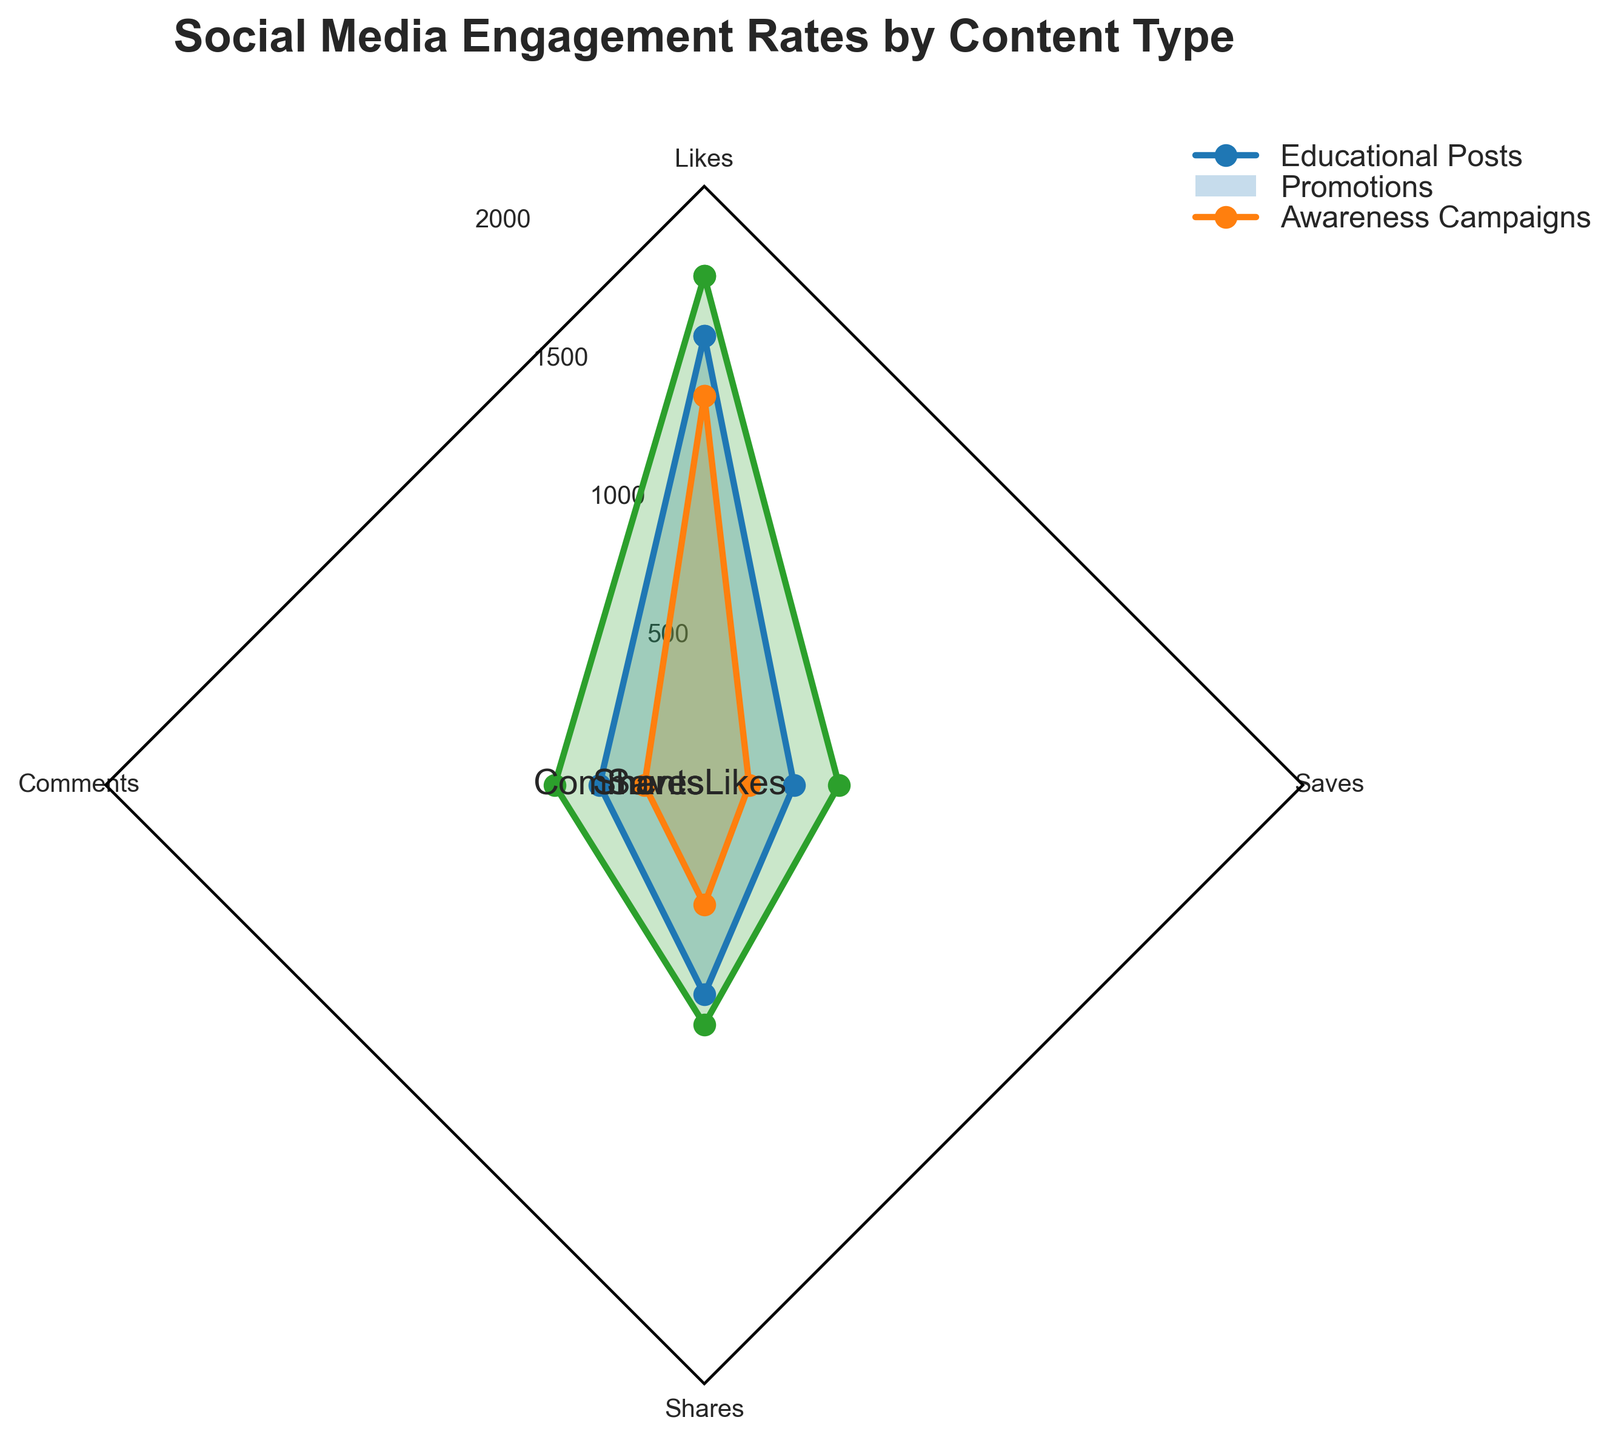What is the title of the radar chart? The title is displayed prominently at the top of the chart. It summarizes the content of the chart.
Answer: Social Media Engagement Rates by Content Type How many content types are represented in the chart? The chart has lines connecting data points labeled with content types. By counting the spokes, we determine the number of content types.
Answer: 4 Which content type has the highest number of likes? By looking at the lines extending furthest from the center on the "Likes" spoke, we can see which one has the highest value.
Answer: Awareness Campaigns Which engagement metric has the lowest value for Promotions? By inspecting the spokes labeled with metrics and checking the extension of the line for Promotions, we find the lowest point.
Answer: Saves What is the total number of comments for Educational Posts and Promotions combined? By adding the values from the "Comments" spoke for both Educational Posts and Promotions.
Answer: 550 How does the number of shares for Awareness Campaigns compare to Promotions? We compare the line extents for both Awareness Campaigns and Promotions on the "Shares" spoke.
Answer: Awareness Campaigns > Promotions What is the average number of saves across all content types? We sum the values for "Saves" for each content type and divide by the number of content types. (300 + 150 + 450) / 3
Answer: 300 Which engagement metric shows the smallest difference between Educational Posts and Promotions? We calculate the differences for each metric and compare them. The smallest difference is in the metric with the closest values.
Answer: Comments How do promotions perform in terms of likes and shares? By comparing the extension of the line for Promotions on the "Likes" and "Shares" spokes, we observe the values.
Answer: Less in Likes, even less in Shares Which content type has consistently higher engagement across all metrics compared to the others? We observe the lines extending furthest across all spokes for a consistent content type, indicating higher values.
Answer: Awareness Campaigns 